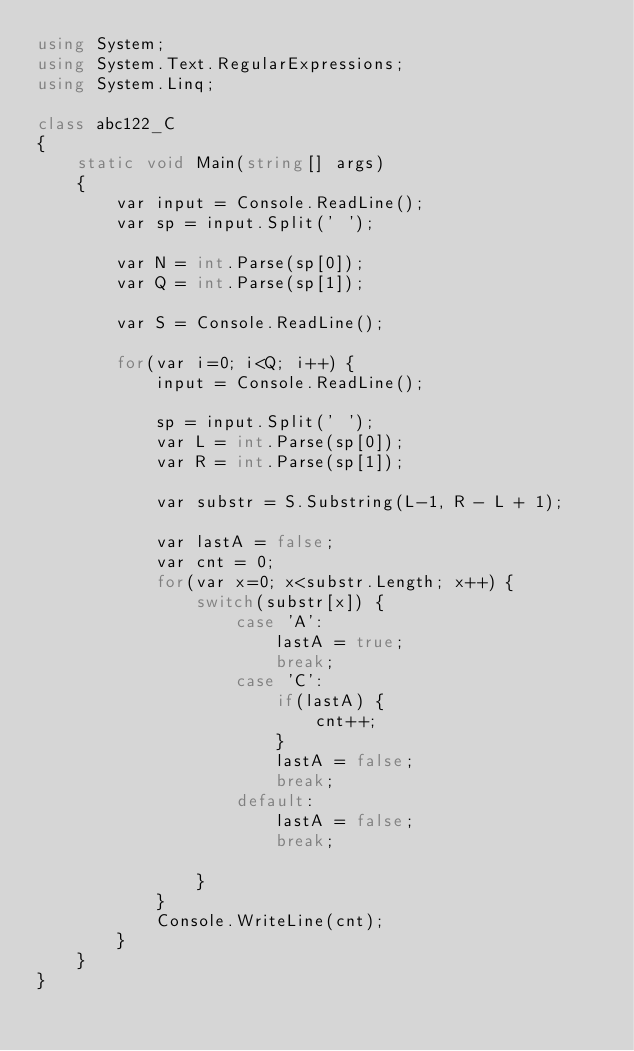Convert code to text. <code><loc_0><loc_0><loc_500><loc_500><_C#_>using System;
using System.Text.RegularExpressions;
using System.Linq;

class abc122_C
{
    static void Main(string[] args)
    {
        var input = Console.ReadLine();
        var sp = input.Split(' ');

        var N = int.Parse(sp[0]);
        var Q = int.Parse(sp[1]);

        var S = Console.ReadLine();

        for(var i=0; i<Q; i++) {
            input = Console.ReadLine();

            sp = input.Split(' ');
            var L = int.Parse(sp[0]);
            var R = int.Parse(sp[1]);

            var substr = S.Substring(L-1, R - L + 1);

            var lastA = false;
            var cnt = 0;
            for(var x=0; x<substr.Length; x++) {
                switch(substr[x]) {
                    case 'A':
                        lastA = true;
                        break;
                    case 'C':
                        if(lastA) {
                            cnt++;
                        }
                        lastA = false;
                        break;
                    default:
                        lastA = false;
                        break;

                }
            }
            Console.WriteLine(cnt);
        }
    }
}</code> 